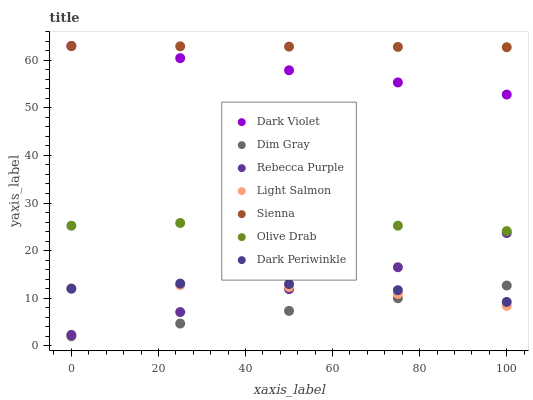Does Dim Gray have the minimum area under the curve?
Answer yes or no. Yes. Does Sienna have the maximum area under the curve?
Answer yes or no. Yes. Does Dark Violet have the minimum area under the curve?
Answer yes or no. No. Does Dark Violet have the maximum area under the curve?
Answer yes or no. No. Is Dark Violet the smoothest?
Answer yes or no. Yes. Is Dark Periwinkle the roughest?
Answer yes or no. Yes. Is Dim Gray the smoothest?
Answer yes or no. No. Is Dim Gray the roughest?
Answer yes or no. No. Does Dim Gray have the lowest value?
Answer yes or no. Yes. Does Dark Violet have the lowest value?
Answer yes or no. No. Does Sienna have the highest value?
Answer yes or no. Yes. Does Dim Gray have the highest value?
Answer yes or no. No. Is Olive Drab less than Sienna?
Answer yes or no. Yes. Is Dark Violet greater than Olive Drab?
Answer yes or no. Yes. Does Dim Gray intersect Light Salmon?
Answer yes or no. Yes. Is Dim Gray less than Light Salmon?
Answer yes or no. No. Is Dim Gray greater than Light Salmon?
Answer yes or no. No. Does Olive Drab intersect Sienna?
Answer yes or no. No. 